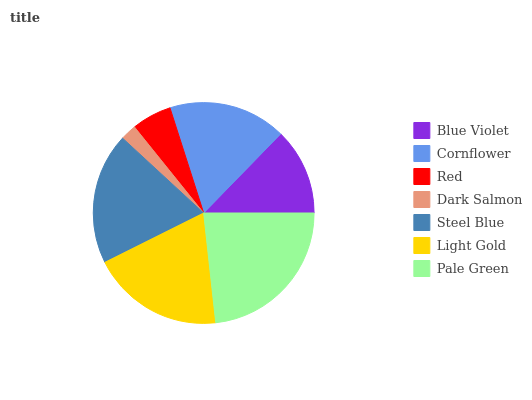Is Dark Salmon the minimum?
Answer yes or no. Yes. Is Pale Green the maximum?
Answer yes or no. Yes. Is Cornflower the minimum?
Answer yes or no. No. Is Cornflower the maximum?
Answer yes or no. No. Is Cornflower greater than Blue Violet?
Answer yes or no. Yes. Is Blue Violet less than Cornflower?
Answer yes or no. Yes. Is Blue Violet greater than Cornflower?
Answer yes or no. No. Is Cornflower less than Blue Violet?
Answer yes or no. No. Is Cornflower the high median?
Answer yes or no. Yes. Is Cornflower the low median?
Answer yes or no. Yes. Is Blue Violet the high median?
Answer yes or no. No. Is Blue Violet the low median?
Answer yes or no. No. 